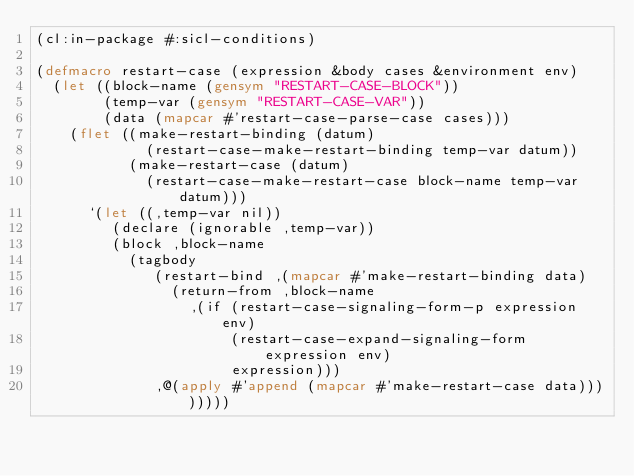<code> <loc_0><loc_0><loc_500><loc_500><_Lisp_>(cl:in-package #:sicl-conditions)

(defmacro restart-case (expression &body cases &environment env)
  (let ((block-name (gensym "RESTART-CASE-BLOCK"))
        (temp-var (gensym "RESTART-CASE-VAR"))
        (data (mapcar #'restart-case-parse-case cases)))
    (flet ((make-restart-binding (datum)
             (restart-case-make-restart-binding temp-var datum))
           (make-restart-case (datum)
             (restart-case-make-restart-case block-name temp-var datum)))
      `(let ((,temp-var nil))
         (declare (ignorable ,temp-var))
         (block ,block-name
           (tagbody
              (restart-bind ,(mapcar #'make-restart-binding data)
                (return-from ,block-name
                  ,(if (restart-case-signaling-form-p expression env)
                       (restart-case-expand-signaling-form expression env)
                       expression)))
              ,@(apply #'append (mapcar #'make-restart-case data))))))))
</code> 